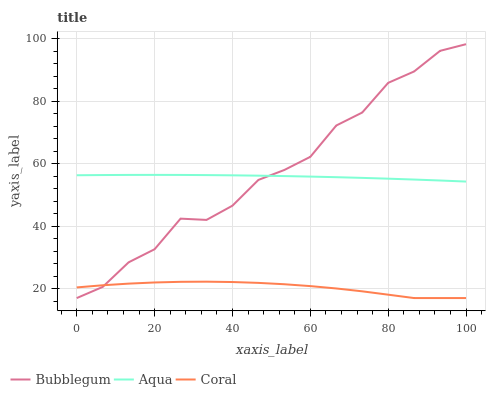Does Coral have the minimum area under the curve?
Answer yes or no. Yes. Does Bubblegum have the maximum area under the curve?
Answer yes or no. Yes. Does Aqua have the minimum area under the curve?
Answer yes or no. No. Does Aqua have the maximum area under the curve?
Answer yes or no. No. Is Aqua the smoothest?
Answer yes or no. Yes. Is Bubblegum the roughest?
Answer yes or no. Yes. Is Bubblegum the smoothest?
Answer yes or no. No. Is Aqua the roughest?
Answer yes or no. No. Does Coral have the lowest value?
Answer yes or no. Yes. Does Aqua have the lowest value?
Answer yes or no. No. Does Bubblegum have the highest value?
Answer yes or no. Yes. Does Aqua have the highest value?
Answer yes or no. No. Is Coral less than Aqua?
Answer yes or no. Yes. Is Aqua greater than Coral?
Answer yes or no. Yes. Does Coral intersect Bubblegum?
Answer yes or no. Yes. Is Coral less than Bubblegum?
Answer yes or no. No. Is Coral greater than Bubblegum?
Answer yes or no. No. Does Coral intersect Aqua?
Answer yes or no. No. 